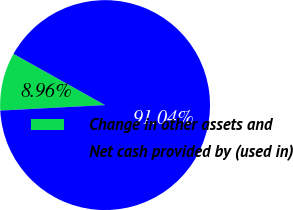Convert chart. <chart><loc_0><loc_0><loc_500><loc_500><pie_chart><fcel>Change in other assets and<fcel>Net cash provided by (used in)<nl><fcel>8.96%<fcel>91.04%<nl></chart> 